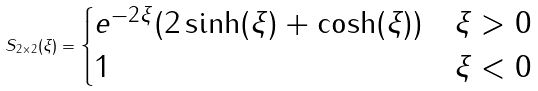<formula> <loc_0><loc_0><loc_500><loc_500>S _ { 2 \times 2 } ( \xi ) = \begin{cases} e ^ { - 2 \xi } ( 2 \sinh ( \xi ) + \cosh ( \xi ) ) & \xi > 0 \\ 1 & \xi < 0 \end{cases}</formula> 